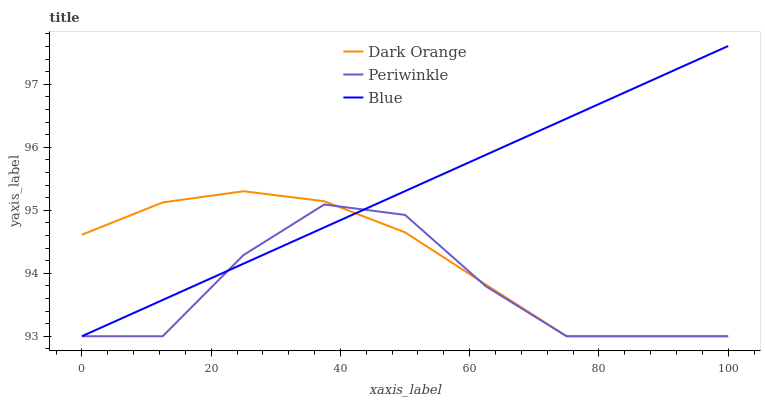Does Dark Orange have the minimum area under the curve?
Answer yes or no. No. Does Dark Orange have the maximum area under the curve?
Answer yes or no. No. Is Dark Orange the smoothest?
Answer yes or no. No. Is Dark Orange the roughest?
Answer yes or no. No. Does Dark Orange have the highest value?
Answer yes or no. No. 